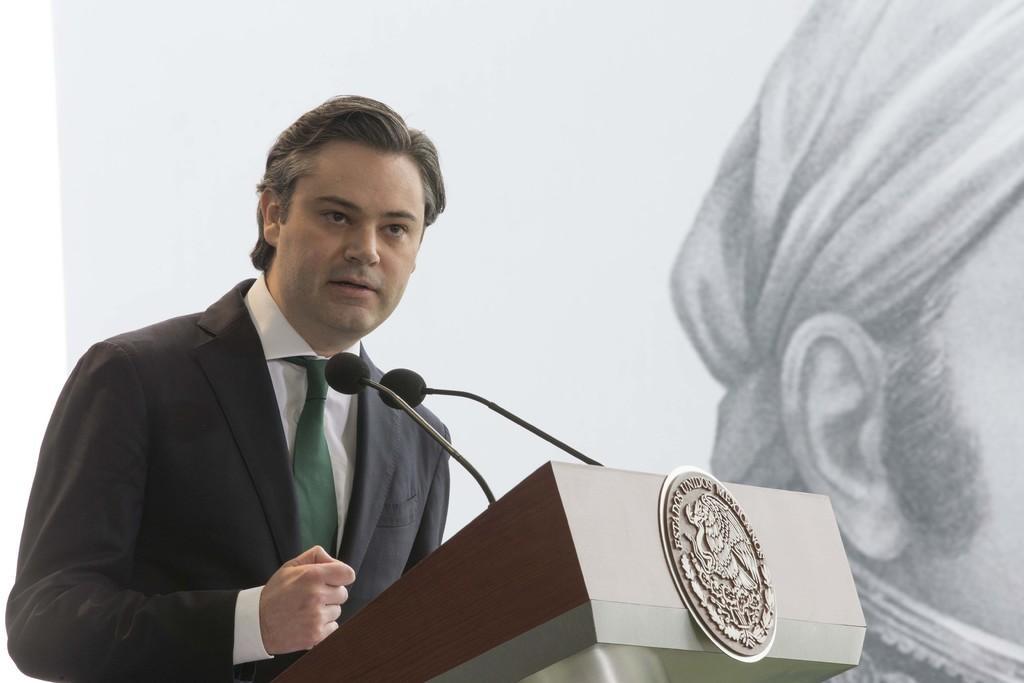Can you describe this image briefly? In this image we can see a man standing in front of the podium and also the mikes. In the background, we can see the depiction of a person on the wall. 